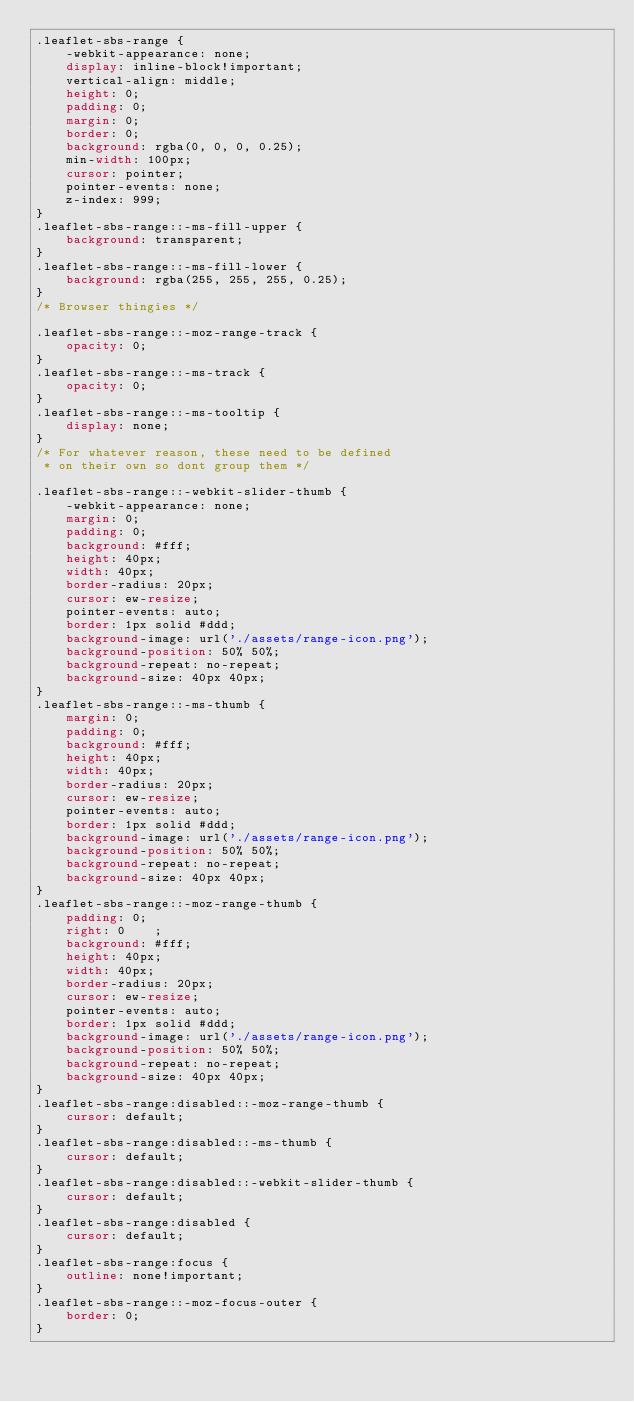Convert code to text. <code><loc_0><loc_0><loc_500><loc_500><_CSS_>.leaflet-sbs-range {
    -webkit-appearance: none;
    display: inline-block!important;
    vertical-align: middle;
    height: 0;
    padding: 0;
    margin: 0;
    border: 0;
    background: rgba(0, 0, 0, 0.25);
    min-width: 100px;
    cursor: pointer;
    pointer-events: none;
    z-index: 999;
}
.leaflet-sbs-range::-ms-fill-upper {
    background: transparent;
}
.leaflet-sbs-range::-ms-fill-lower {
    background: rgba(255, 255, 255, 0.25);
}
/* Browser thingies */

.leaflet-sbs-range::-moz-range-track {
    opacity: 0;
}
.leaflet-sbs-range::-ms-track {
    opacity: 0;
}
.leaflet-sbs-range::-ms-tooltip {
    display: none;
}
/* For whatever reason, these need to be defined
 * on their own so dont group them */

.leaflet-sbs-range::-webkit-slider-thumb {
    -webkit-appearance: none;
    margin: 0;
    padding: 0;
    background: #fff;
    height: 40px;
    width: 40px;
    border-radius: 20px;
    cursor: ew-resize;
    pointer-events: auto;
    border: 1px solid #ddd;
    background-image: url('./assets/range-icon.png');
    background-position: 50% 50%;
    background-repeat: no-repeat;
    background-size: 40px 40px;
}
.leaflet-sbs-range::-ms-thumb {
    margin: 0;
    padding: 0;
    background: #fff;
    height: 40px;
    width: 40px;
    border-radius: 20px;
    cursor: ew-resize;
    pointer-events: auto;
    border: 1px solid #ddd;
    background-image: url('./assets/range-icon.png');
    background-position: 50% 50%;
    background-repeat: no-repeat;
    background-size: 40px 40px;
}
.leaflet-sbs-range::-moz-range-thumb {
    padding: 0;
    right: 0    ;
    background: #fff;
    height: 40px;
    width: 40px;
    border-radius: 20px;
    cursor: ew-resize;
    pointer-events: auto;
    border: 1px solid #ddd;
    background-image: url('./assets/range-icon.png');
    background-position: 50% 50%;
    background-repeat: no-repeat;
    background-size: 40px 40px;
}
.leaflet-sbs-range:disabled::-moz-range-thumb {
    cursor: default;
}
.leaflet-sbs-range:disabled::-ms-thumb {
    cursor: default;
}
.leaflet-sbs-range:disabled::-webkit-slider-thumb {
    cursor: default;
}
.leaflet-sbs-range:disabled {
    cursor: default;
}
.leaflet-sbs-range:focus {
    outline: none!important;
}
.leaflet-sbs-range::-moz-focus-outer {
    border: 0;
}
</code> 